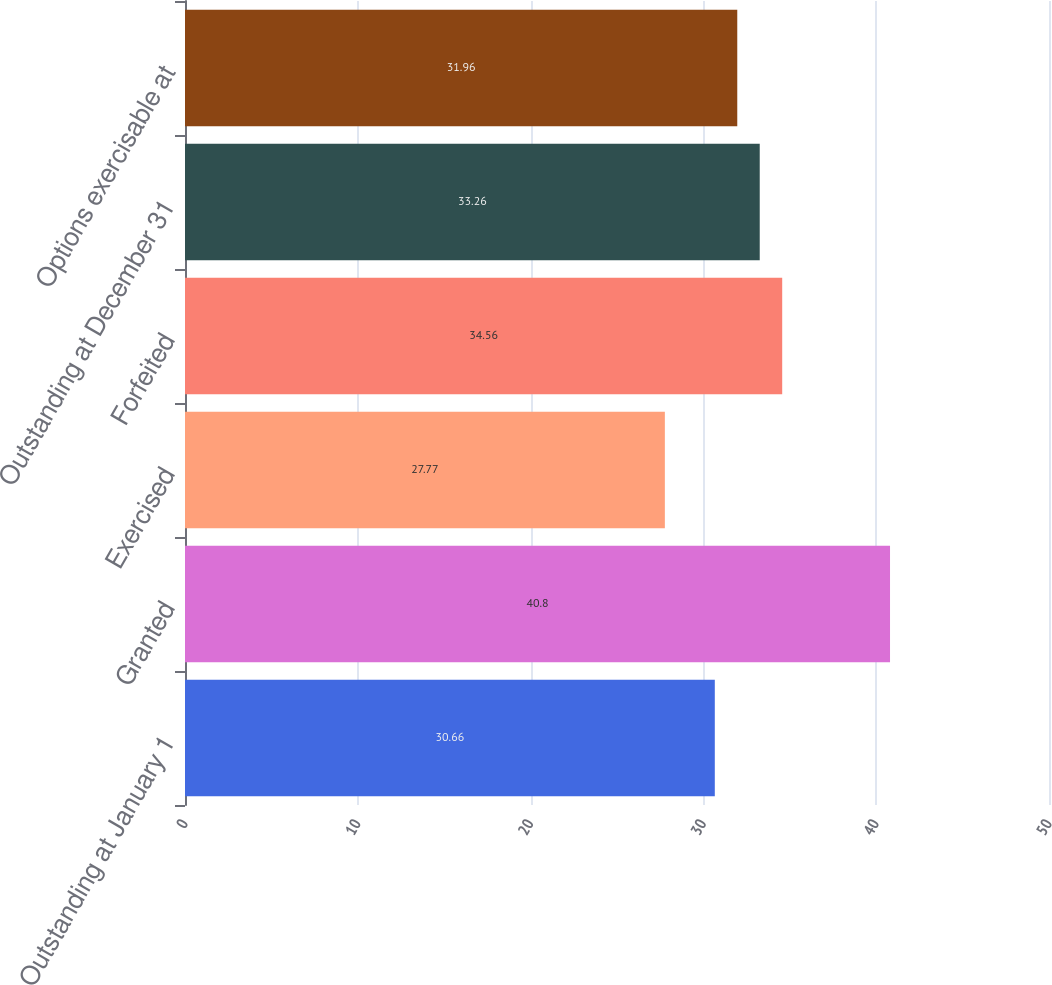Convert chart to OTSL. <chart><loc_0><loc_0><loc_500><loc_500><bar_chart><fcel>Outstanding at January 1<fcel>Granted<fcel>Exercised<fcel>Forfeited<fcel>Outstanding at December 31<fcel>Options exercisable at<nl><fcel>30.66<fcel>40.8<fcel>27.77<fcel>34.56<fcel>33.26<fcel>31.96<nl></chart> 